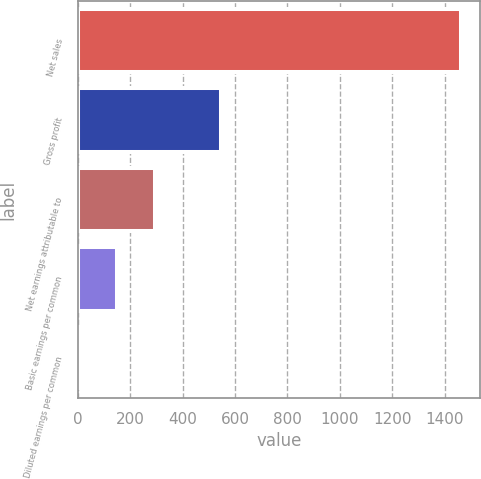Convert chart. <chart><loc_0><loc_0><loc_500><loc_500><bar_chart><fcel>Net sales<fcel>Gross profit<fcel>Net earnings attributable to<fcel>Basic earnings per common<fcel>Diluted earnings per common<nl><fcel>1462.2<fcel>547.6<fcel>293.75<fcel>147.69<fcel>1.63<nl></chart> 